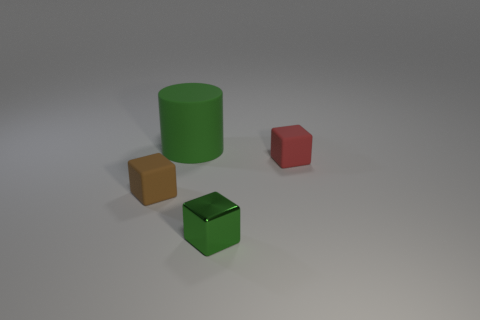The rubber cylinder has what size?
Your answer should be very brief. Large. There is a tiny object that is right of the green cube; does it have the same color as the small metallic block?
Provide a succinct answer. No. Is there anything else that is the same shape as the small green shiny thing?
Make the answer very short. Yes. There is a rubber cube that is on the left side of the small green cube; is there a large green object that is behind it?
Make the answer very short. Yes. Are there fewer small matte objects right of the metal object than cylinders that are left of the large green object?
Your response must be concise. No. There is a rubber block that is on the left side of the small rubber cube that is right of the matte thing that is behind the tiny red block; what size is it?
Keep it short and to the point. Small. There is a green thing that is on the left side of the green shiny block; is its size the same as the small brown rubber cube?
Offer a terse response. No. How many other things are there of the same material as the tiny red object?
Offer a terse response. 2. Are there more small green cylinders than brown objects?
Ensure brevity in your answer.  No. There is a thing behind the thing that is to the right of the shiny object on the left side of the red object; what is its material?
Offer a very short reply. Rubber. 